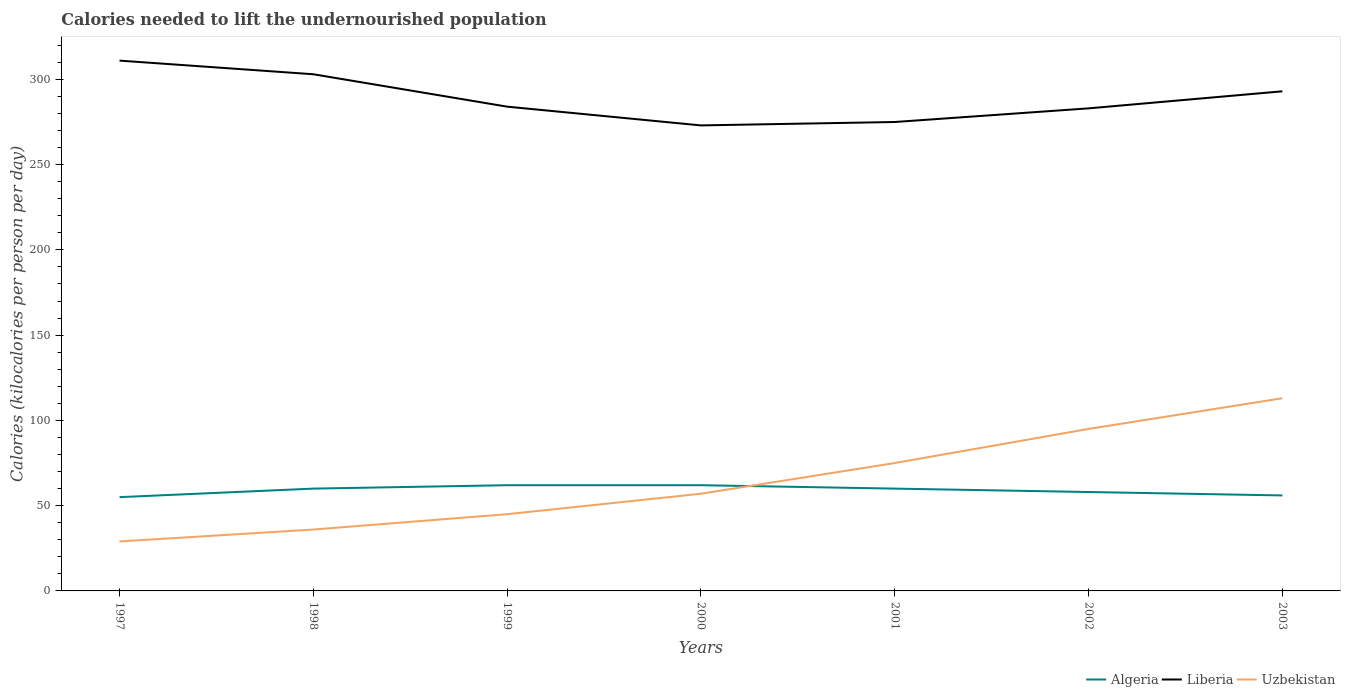Does the line corresponding to Algeria intersect with the line corresponding to Uzbekistan?
Offer a terse response. Yes. Is the number of lines equal to the number of legend labels?
Give a very brief answer. Yes. Across all years, what is the maximum total calories needed to lift the undernourished population in Liberia?
Give a very brief answer. 273. What is the total total calories needed to lift the undernourished population in Uzbekistan in the graph?
Make the answer very short. -28. What is the difference between the highest and the second highest total calories needed to lift the undernourished population in Uzbekistan?
Make the answer very short. 84. Does the graph contain grids?
Your answer should be compact. No. What is the title of the graph?
Ensure brevity in your answer.  Calories needed to lift the undernourished population. Does "Burundi" appear as one of the legend labels in the graph?
Offer a terse response. No. What is the label or title of the Y-axis?
Your answer should be very brief. Calories (kilocalories per person per day). What is the Calories (kilocalories per person per day) of Algeria in 1997?
Make the answer very short. 55. What is the Calories (kilocalories per person per day) in Liberia in 1997?
Provide a short and direct response. 311. What is the Calories (kilocalories per person per day) in Uzbekistan in 1997?
Your answer should be compact. 29. What is the Calories (kilocalories per person per day) in Algeria in 1998?
Ensure brevity in your answer.  60. What is the Calories (kilocalories per person per day) of Liberia in 1998?
Provide a short and direct response. 303. What is the Calories (kilocalories per person per day) of Liberia in 1999?
Your answer should be compact. 284. What is the Calories (kilocalories per person per day) of Liberia in 2000?
Keep it short and to the point. 273. What is the Calories (kilocalories per person per day) in Uzbekistan in 2000?
Your answer should be compact. 57. What is the Calories (kilocalories per person per day) in Liberia in 2001?
Provide a succinct answer. 275. What is the Calories (kilocalories per person per day) in Algeria in 2002?
Ensure brevity in your answer.  58. What is the Calories (kilocalories per person per day) of Liberia in 2002?
Provide a succinct answer. 283. What is the Calories (kilocalories per person per day) in Liberia in 2003?
Provide a short and direct response. 293. What is the Calories (kilocalories per person per day) in Uzbekistan in 2003?
Your answer should be compact. 113. Across all years, what is the maximum Calories (kilocalories per person per day) of Liberia?
Offer a terse response. 311. Across all years, what is the maximum Calories (kilocalories per person per day) of Uzbekistan?
Make the answer very short. 113. Across all years, what is the minimum Calories (kilocalories per person per day) in Liberia?
Your answer should be very brief. 273. Across all years, what is the minimum Calories (kilocalories per person per day) of Uzbekistan?
Provide a succinct answer. 29. What is the total Calories (kilocalories per person per day) of Algeria in the graph?
Your response must be concise. 413. What is the total Calories (kilocalories per person per day) in Liberia in the graph?
Your answer should be compact. 2022. What is the total Calories (kilocalories per person per day) of Uzbekistan in the graph?
Offer a very short reply. 450. What is the difference between the Calories (kilocalories per person per day) of Liberia in 1997 and that in 1998?
Make the answer very short. 8. What is the difference between the Calories (kilocalories per person per day) in Uzbekistan in 1997 and that in 1998?
Your response must be concise. -7. What is the difference between the Calories (kilocalories per person per day) in Algeria in 1997 and that in 1999?
Provide a succinct answer. -7. What is the difference between the Calories (kilocalories per person per day) in Uzbekistan in 1997 and that in 1999?
Offer a terse response. -16. What is the difference between the Calories (kilocalories per person per day) in Algeria in 1997 and that in 2000?
Ensure brevity in your answer.  -7. What is the difference between the Calories (kilocalories per person per day) in Liberia in 1997 and that in 2000?
Offer a terse response. 38. What is the difference between the Calories (kilocalories per person per day) in Uzbekistan in 1997 and that in 2000?
Ensure brevity in your answer.  -28. What is the difference between the Calories (kilocalories per person per day) of Uzbekistan in 1997 and that in 2001?
Keep it short and to the point. -46. What is the difference between the Calories (kilocalories per person per day) of Algeria in 1997 and that in 2002?
Your answer should be very brief. -3. What is the difference between the Calories (kilocalories per person per day) in Liberia in 1997 and that in 2002?
Ensure brevity in your answer.  28. What is the difference between the Calories (kilocalories per person per day) of Uzbekistan in 1997 and that in 2002?
Your answer should be very brief. -66. What is the difference between the Calories (kilocalories per person per day) in Uzbekistan in 1997 and that in 2003?
Your answer should be very brief. -84. What is the difference between the Calories (kilocalories per person per day) in Algeria in 1998 and that in 1999?
Keep it short and to the point. -2. What is the difference between the Calories (kilocalories per person per day) of Liberia in 1998 and that in 1999?
Provide a succinct answer. 19. What is the difference between the Calories (kilocalories per person per day) in Uzbekistan in 1998 and that in 1999?
Your answer should be very brief. -9. What is the difference between the Calories (kilocalories per person per day) in Uzbekistan in 1998 and that in 2000?
Offer a terse response. -21. What is the difference between the Calories (kilocalories per person per day) of Algeria in 1998 and that in 2001?
Give a very brief answer. 0. What is the difference between the Calories (kilocalories per person per day) in Uzbekistan in 1998 and that in 2001?
Offer a terse response. -39. What is the difference between the Calories (kilocalories per person per day) of Uzbekistan in 1998 and that in 2002?
Provide a succinct answer. -59. What is the difference between the Calories (kilocalories per person per day) of Liberia in 1998 and that in 2003?
Your response must be concise. 10. What is the difference between the Calories (kilocalories per person per day) of Uzbekistan in 1998 and that in 2003?
Your response must be concise. -77. What is the difference between the Calories (kilocalories per person per day) in Algeria in 1999 and that in 2000?
Provide a succinct answer. 0. What is the difference between the Calories (kilocalories per person per day) in Liberia in 1999 and that in 2000?
Keep it short and to the point. 11. What is the difference between the Calories (kilocalories per person per day) of Algeria in 1999 and that in 2001?
Ensure brevity in your answer.  2. What is the difference between the Calories (kilocalories per person per day) of Liberia in 1999 and that in 2001?
Offer a very short reply. 9. What is the difference between the Calories (kilocalories per person per day) of Uzbekistan in 1999 and that in 2001?
Your answer should be very brief. -30. What is the difference between the Calories (kilocalories per person per day) of Liberia in 1999 and that in 2002?
Provide a short and direct response. 1. What is the difference between the Calories (kilocalories per person per day) of Algeria in 1999 and that in 2003?
Provide a succinct answer. 6. What is the difference between the Calories (kilocalories per person per day) of Uzbekistan in 1999 and that in 2003?
Give a very brief answer. -68. What is the difference between the Calories (kilocalories per person per day) in Algeria in 2000 and that in 2001?
Offer a terse response. 2. What is the difference between the Calories (kilocalories per person per day) in Liberia in 2000 and that in 2001?
Give a very brief answer. -2. What is the difference between the Calories (kilocalories per person per day) of Uzbekistan in 2000 and that in 2001?
Provide a short and direct response. -18. What is the difference between the Calories (kilocalories per person per day) of Liberia in 2000 and that in 2002?
Your answer should be very brief. -10. What is the difference between the Calories (kilocalories per person per day) of Uzbekistan in 2000 and that in 2002?
Provide a short and direct response. -38. What is the difference between the Calories (kilocalories per person per day) in Liberia in 2000 and that in 2003?
Give a very brief answer. -20. What is the difference between the Calories (kilocalories per person per day) in Uzbekistan in 2000 and that in 2003?
Offer a terse response. -56. What is the difference between the Calories (kilocalories per person per day) of Liberia in 2001 and that in 2002?
Provide a short and direct response. -8. What is the difference between the Calories (kilocalories per person per day) of Uzbekistan in 2001 and that in 2002?
Offer a terse response. -20. What is the difference between the Calories (kilocalories per person per day) in Liberia in 2001 and that in 2003?
Ensure brevity in your answer.  -18. What is the difference between the Calories (kilocalories per person per day) of Uzbekistan in 2001 and that in 2003?
Give a very brief answer. -38. What is the difference between the Calories (kilocalories per person per day) of Algeria in 2002 and that in 2003?
Make the answer very short. 2. What is the difference between the Calories (kilocalories per person per day) of Liberia in 2002 and that in 2003?
Provide a short and direct response. -10. What is the difference between the Calories (kilocalories per person per day) in Algeria in 1997 and the Calories (kilocalories per person per day) in Liberia in 1998?
Keep it short and to the point. -248. What is the difference between the Calories (kilocalories per person per day) of Algeria in 1997 and the Calories (kilocalories per person per day) of Uzbekistan in 1998?
Make the answer very short. 19. What is the difference between the Calories (kilocalories per person per day) in Liberia in 1997 and the Calories (kilocalories per person per day) in Uzbekistan in 1998?
Keep it short and to the point. 275. What is the difference between the Calories (kilocalories per person per day) in Algeria in 1997 and the Calories (kilocalories per person per day) in Liberia in 1999?
Offer a very short reply. -229. What is the difference between the Calories (kilocalories per person per day) in Algeria in 1997 and the Calories (kilocalories per person per day) in Uzbekistan in 1999?
Your answer should be very brief. 10. What is the difference between the Calories (kilocalories per person per day) of Liberia in 1997 and the Calories (kilocalories per person per day) of Uzbekistan in 1999?
Offer a terse response. 266. What is the difference between the Calories (kilocalories per person per day) in Algeria in 1997 and the Calories (kilocalories per person per day) in Liberia in 2000?
Keep it short and to the point. -218. What is the difference between the Calories (kilocalories per person per day) in Algeria in 1997 and the Calories (kilocalories per person per day) in Uzbekistan in 2000?
Your response must be concise. -2. What is the difference between the Calories (kilocalories per person per day) in Liberia in 1997 and the Calories (kilocalories per person per day) in Uzbekistan in 2000?
Your answer should be compact. 254. What is the difference between the Calories (kilocalories per person per day) of Algeria in 1997 and the Calories (kilocalories per person per day) of Liberia in 2001?
Provide a succinct answer. -220. What is the difference between the Calories (kilocalories per person per day) in Algeria in 1997 and the Calories (kilocalories per person per day) in Uzbekistan in 2001?
Give a very brief answer. -20. What is the difference between the Calories (kilocalories per person per day) of Liberia in 1997 and the Calories (kilocalories per person per day) of Uzbekistan in 2001?
Give a very brief answer. 236. What is the difference between the Calories (kilocalories per person per day) of Algeria in 1997 and the Calories (kilocalories per person per day) of Liberia in 2002?
Offer a terse response. -228. What is the difference between the Calories (kilocalories per person per day) of Liberia in 1997 and the Calories (kilocalories per person per day) of Uzbekistan in 2002?
Your response must be concise. 216. What is the difference between the Calories (kilocalories per person per day) of Algeria in 1997 and the Calories (kilocalories per person per day) of Liberia in 2003?
Keep it short and to the point. -238. What is the difference between the Calories (kilocalories per person per day) in Algeria in 1997 and the Calories (kilocalories per person per day) in Uzbekistan in 2003?
Provide a short and direct response. -58. What is the difference between the Calories (kilocalories per person per day) of Liberia in 1997 and the Calories (kilocalories per person per day) of Uzbekistan in 2003?
Your answer should be very brief. 198. What is the difference between the Calories (kilocalories per person per day) in Algeria in 1998 and the Calories (kilocalories per person per day) in Liberia in 1999?
Keep it short and to the point. -224. What is the difference between the Calories (kilocalories per person per day) in Liberia in 1998 and the Calories (kilocalories per person per day) in Uzbekistan in 1999?
Keep it short and to the point. 258. What is the difference between the Calories (kilocalories per person per day) in Algeria in 1998 and the Calories (kilocalories per person per day) in Liberia in 2000?
Offer a terse response. -213. What is the difference between the Calories (kilocalories per person per day) of Liberia in 1998 and the Calories (kilocalories per person per day) of Uzbekistan in 2000?
Provide a short and direct response. 246. What is the difference between the Calories (kilocalories per person per day) of Algeria in 1998 and the Calories (kilocalories per person per day) of Liberia in 2001?
Give a very brief answer. -215. What is the difference between the Calories (kilocalories per person per day) of Algeria in 1998 and the Calories (kilocalories per person per day) of Uzbekistan in 2001?
Provide a succinct answer. -15. What is the difference between the Calories (kilocalories per person per day) in Liberia in 1998 and the Calories (kilocalories per person per day) in Uzbekistan in 2001?
Give a very brief answer. 228. What is the difference between the Calories (kilocalories per person per day) in Algeria in 1998 and the Calories (kilocalories per person per day) in Liberia in 2002?
Ensure brevity in your answer.  -223. What is the difference between the Calories (kilocalories per person per day) in Algeria in 1998 and the Calories (kilocalories per person per day) in Uzbekistan in 2002?
Offer a terse response. -35. What is the difference between the Calories (kilocalories per person per day) in Liberia in 1998 and the Calories (kilocalories per person per day) in Uzbekistan in 2002?
Offer a very short reply. 208. What is the difference between the Calories (kilocalories per person per day) in Algeria in 1998 and the Calories (kilocalories per person per day) in Liberia in 2003?
Give a very brief answer. -233. What is the difference between the Calories (kilocalories per person per day) of Algeria in 1998 and the Calories (kilocalories per person per day) of Uzbekistan in 2003?
Provide a succinct answer. -53. What is the difference between the Calories (kilocalories per person per day) in Liberia in 1998 and the Calories (kilocalories per person per day) in Uzbekistan in 2003?
Provide a short and direct response. 190. What is the difference between the Calories (kilocalories per person per day) in Algeria in 1999 and the Calories (kilocalories per person per day) in Liberia in 2000?
Your answer should be very brief. -211. What is the difference between the Calories (kilocalories per person per day) of Algeria in 1999 and the Calories (kilocalories per person per day) of Uzbekistan in 2000?
Make the answer very short. 5. What is the difference between the Calories (kilocalories per person per day) of Liberia in 1999 and the Calories (kilocalories per person per day) of Uzbekistan in 2000?
Offer a terse response. 227. What is the difference between the Calories (kilocalories per person per day) of Algeria in 1999 and the Calories (kilocalories per person per day) of Liberia in 2001?
Your response must be concise. -213. What is the difference between the Calories (kilocalories per person per day) of Algeria in 1999 and the Calories (kilocalories per person per day) of Uzbekistan in 2001?
Your answer should be compact. -13. What is the difference between the Calories (kilocalories per person per day) of Liberia in 1999 and the Calories (kilocalories per person per day) of Uzbekistan in 2001?
Your answer should be compact. 209. What is the difference between the Calories (kilocalories per person per day) in Algeria in 1999 and the Calories (kilocalories per person per day) in Liberia in 2002?
Offer a very short reply. -221. What is the difference between the Calories (kilocalories per person per day) of Algeria in 1999 and the Calories (kilocalories per person per day) of Uzbekistan in 2002?
Keep it short and to the point. -33. What is the difference between the Calories (kilocalories per person per day) of Liberia in 1999 and the Calories (kilocalories per person per day) of Uzbekistan in 2002?
Offer a very short reply. 189. What is the difference between the Calories (kilocalories per person per day) in Algeria in 1999 and the Calories (kilocalories per person per day) in Liberia in 2003?
Give a very brief answer. -231. What is the difference between the Calories (kilocalories per person per day) of Algeria in 1999 and the Calories (kilocalories per person per day) of Uzbekistan in 2003?
Your answer should be compact. -51. What is the difference between the Calories (kilocalories per person per day) in Liberia in 1999 and the Calories (kilocalories per person per day) in Uzbekistan in 2003?
Your answer should be very brief. 171. What is the difference between the Calories (kilocalories per person per day) of Algeria in 2000 and the Calories (kilocalories per person per day) of Liberia in 2001?
Ensure brevity in your answer.  -213. What is the difference between the Calories (kilocalories per person per day) of Algeria in 2000 and the Calories (kilocalories per person per day) of Uzbekistan in 2001?
Provide a short and direct response. -13. What is the difference between the Calories (kilocalories per person per day) in Liberia in 2000 and the Calories (kilocalories per person per day) in Uzbekistan in 2001?
Make the answer very short. 198. What is the difference between the Calories (kilocalories per person per day) of Algeria in 2000 and the Calories (kilocalories per person per day) of Liberia in 2002?
Offer a terse response. -221. What is the difference between the Calories (kilocalories per person per day) of Algeria in 2000 and the Calories (kilocalories per person per day) of Uzbekistan in 2002?
Keep it short and to the point. -33. What is the difference between the Calories (kilocalories per person per day) in Liberia in 2000 and the Calories (kilocalories per person per day) in Uzbekistan in 2002?
Offer a terse response. 178. What is the difference between the Calories (kilocalories per person per day) in Algeria in 2000 and the Calories (kilocalories per person per day) in Liberia in 2003?
Keep it short and to the point. -231. What is the difference between the Calories (kilocalories per person per day) of Algeria in 2000 and the Calories (kilocalories per person per day) of Uzbekistan in 2003?
Your answer should be compact. -51. What is the difference between the Calories (kilocalories per person per day) of Liberia in 2000 and the Calories (kilocalories per person per day) of Uzbekistan in 2003?
Provide a short and direct response. 160. What is the difference between the Calories (kilocalories per person per day) of Algeria in 2001 and the Calories (kilocalories per person per day) of Liberia in 2002?
Give a very brief answer. -223. What is the difference between the Calories (kilocalories per person per day) in Algeria in 2001 and the Calories (kilocalories per person per day) in Uzbekistan in 2002?
Offer a terse response. -35. What is the difference between the Calories (kilocalories per person per day) in Liberia in 2001 and the Calories (kilocalories per person per day) in Uzbekistan in 2002?
Your answer should be compact. 180. What is the difference between the Calories (kilocalories per person per day) of Algeria in 2001 and the Calories (kilocalories per person per day) of Liberia in 2003?
Your answer should be very brief. -233. What is the difference between the Calories (kilocalories per person per day) of Algeria in 2001 and the Calories (kilocalories per person per day) of Uzbekistan in 2003?
Provide a short and direct response. -53. What is the difference between the Calories (kilocalories per person per day) of Liberia in 2001 and the Calories (kilocalories per person per day) of Uzbekistan in 2003?
Your answer should be very brief. 162. What is the difference between the Calories (kilocalories per person per day) in Algeria in 2002 and the Calories (kilocalories per person per day) in Liberia in 2003?
Make the answer very short. -235. What is the difference between the Calories (kilocalories per person per day) of Algeria in 2002 and the Calories (kilocalories per person per day) of Uzbekistan in 2003?
Offer a terse response. -55. What is the difference between the Calories (kilocalories per person per day) of Liberia in 2002 and the Calories (kilocalories per person per day) of Uzbekistan in 2003?
Make the answer very short. 170. What is the average Calories (kilocalories per person per day) in Algeria per year?
Give a very brief answer. 59. What is the average Calories (kilocalories per person per day) of Liberia per year?
Offer a terse response. 288.86. What is the average Calories (kilocalories per person per day) of Uzbekistan per year?
Your answer should be very brief. 64.29. In the year 1997, what is the difference between the Calories (kilocalories per person per day) in Algeria and Calories (kilocalories per person per day) in Liberia?
Offer a terse response. -256. In the year 1997, what is the difference between the Calories (kilocalories per person per day) in Liberia and Calories (kilocalories per person per day) in Uzbekistan?
Keep it short and to the point. 282. In the year 1998, what is the difference between the Calories (kilocalories per person per day) in Algeria and Calories (kilocalories per person per day) in Liberia?
Keep it short and to the point. -243. In the year 1998, what is the difference between the Calories (kilocalories per person per day) of Algeria and Calories (kilocalories per person per day) of Uzbekistan?
Offer a terse response. 24. In the year 1998, what is the difference between the Calories (kilocalories per person per day) of Liberia and Calories (kilocalories per person per day) of Uzbekistan?
Make the answer very short. 267. In the year 1999, what is the difference between the Calories (kilocalories per person per day) in Algeria and Calories (kilocalories per person per day) in Liberia?
Offer a terse response. -222. In the year 1999, what is the difference between the Calories (kilocalories per person per day) in Algeria and Calories (kilocalories per person per day) in Uzbekistan?
Provide a short and direct response. 17. In the year 1999, what is the difference between the Calories (kilocalories per person per day) in Liberia and Calories (kilocalories per person per day) in Uzbekistan?
Make the answer very short. 239. In the year 2000, what is the difference between the Calories (kilocalories per person per day) of Algeria and Calories (kilocalories per person per day) of Liberia?
Keep it short and to the point. -211. In the year 2000, what is the difference between the Calories (kilocalories per person per day) in Algeria and Calories (kilocalories per person per day) in Uzbekistan?
Keep it short and to the point. 5. In the year 2000, what is the difference between the Calories (kilocalories per person per day) of Liberia and Calories (kilocalories per person per day) of Uzbekistan?
Keep it short and to the point. 216. In the year 2001, what is the difference between the Calories (kilocalories per person per day) of Algeria and Calories (kilocalories per person per day) of Liberia?
Offer a very short reply. -215. In the year 2001, what is the difference between the Calories (kilocalories per person per day) in Algeria and Calories (kilocalories per person per day) in Uzbekistan?
Offer a terse response. -15. In the year 2001, what is the difference between the Calories (kilocalories per person per day) in Liberia and Calories (kilocalories per person per day) in Uzbekistan?
Offer a very short reply. 200. In the year 2002, what is the difference between the Calories (kilocalories per person per day) of Algeria and Calories (kilocalories per person per day) of Liberia?
Keep it short and to the point. -225. In the year 2002, what is the difference between the Calories (kilocalories per person per day) in Algeria and Calories (kilocalories per person per day) in Uzbekistan?
Ensure brevity in your answer.  -37. In the year 2002, what is the difference between the Calories (kilocalories per person per day) of Liberia and Calories (kilocalories per person per day) of Uzbekistan?
Your answer should be compact. 188. In the year 2003, what is the difference between the Calories (kilocalories per person per day) of Algeria and Calories (kilocalories per person per day) of Liberia?
Your response must be concise. -237. In the year 2003, what is the difference between the Calories (kilocalories per person per day) in Algeria and Calories (kilocalories per person per day) in Uzbekistan?
Offer a very short reply. -57. In the year 2003, what is the difference between the Calories (kilocalories per person per day) of Liberia and Calories (kilocalories per person per day) of Uzbekistan?
Offer a very short reply. 180. What is the ratio of the Calories (kilocalories per person per day) of Liberia in 1997 to that in 1998?
Your answer should be compact. 1.03. What is the ratio of the Calories (kilocalories per person per day) in Uzbekistan in 1997 to that in 1998?
Provide a succinct answer. 0.81. What is the ratio of the Calories (kilocalories per person per day) in Algeria in 1997 to that in 1999?
Offer a very short reply. 0.89. What is the ratio of the Calories (kilocalories per person per day) in Liberia in 1997 to that in 1999?
Provide a succinct answer. 1.1. What is the ratio of the Calories (kilocalories per person per day) in Uzbekistan in 1997 to that in 1999?
Provide a succinct answer. 0.64. What is the ratio of the Calories (kilocalories per person per day) in Algeria in 1997 to that in 2000?
Give a very brief answer. 0.89. What is the ratio of the Calories (kilocalories per person per day) in Liberia in 1997 to that in 2000?
Your answer should be very brief. 1.14. What is the ratio of the Calories (kilocalories per person per day) of Uzbekistan in 1997 to that in 2000?
Provide a short and direct response. 0.51. What is the ratio of the Calories (kilocalories per person per day) in Algeria in 1997 to that in 2001?
Provide a succinct answer. 0.92. What is the ratio of the Calories (kilocalories per person per day) in Liberia in 1997 to that in 2001?
Your response must be concise. 1.13. What is the ratio of the Calories (kilocalories per person per day) of Uzbekistan in 1997 to that in 2001?
Offer a terse response. 0.39. What is the ratio of the Calories (kilocalories per person per day) of Algeria in 1997 to that in 2002?
Your response must be concise. 0.95. What is the ratio of the Calories (kilocalories per person per day) in Liberia in 1997 to that in 2002?
Your response must be concise. 1.1. What is the ratio of the Calories (kilocalories per person per day) in Uzbekistan in 1997 to that in 2002?
Your answer should be compact. 0.31. What is the ratio of the Calories (kilocalories per person per day) in Algeria in 1997 to that in 2003?
Offer a very short reply. 0.98. What is the ratio of the Calories (kilocalories per person per day) of Liberia in 1997 to that in 2003?
Make the answer very short. 1.06. What is the ratio of the Calories (kilocalories per person per day) in Uzbekistan in 1997 to that in 2003?
Your answer should be compact. 0.26. What is the ratio of the Calories (kilocalories per person per day) of Algeria in 1998 to that in 1999?
Offer a very short reply. 0.97. What is the ratio of the Calories (kilocalories per person per day) of Liberia in 1998 to that in 1999?
Offer a terse response. 1.07. What is the ratio of the Calories (kilocalories per person per day) in Algeria in 1998 to that in 2000?
Your response must be concise. 0.97. What is the ratio of the Calories (kilocalories per person per day) of Liberia in 1998 to that in 2000?
Provide a short and direct response. 1.11. What is the ratio of the Calories (kilocalories per person per day) of Uzbekistan in 1998 to that in 2000?
Keep it short and to the point. 0.63. What is the ratio of the Calories (kilocalories per person per day) of Algeria in 1998 to that in 2001?
Your answer should be very brief. 1. What is the ratio of the Calories (kilocalories per person per day) in Liberia in 1998 to that in 2001?
Offer a terse response. 1.1. What is the ratio of the Calories (kilocalories per person per day) of Uzbekistan in 1998 to that in 2001?
Ensure brevity in your answer.  0.48. What is the ratio of the Calories (kilocalories per person per day) of Algeria in 1998 to that in 2002?
Your answer should be compact. 1.03. What is the ratio of the Calories (kilocalories per person per day) of Liberia in 1998 to that in 2002?
Your response must be concise. 1.07. What is the ratio of the Calories (kilocalories per person per day) of Uzbekistan in 1998 to that in 2002?
Offer a terse response. 0.38. What is the ratio of the Calories (kilocalories per person per day) of Algeria in 1998 to that in 2003?
Give a very brief answer. 1.07. What is the ratio of the Calories (kilocalories per person per day) in Liberia in 1998 to that in 2003?
Provide a short and direct response. 1.03. What is the ratio of the Calories (kilocalories per person per day) in Uzbekistan in 1998 to that in 2003?
Provide a succinct answer. 0.32. What is the ratio of the Calories (kilocalories per person per day) of Liberia in 1999 to that in 2000?
Give a very brief answer. 1.04. What is the ratio of the Calories (kilocalories per person per day) of Uzbekistan in 1999 to that in 2000?
Your answer should be very brief. 0.79. What is the ratio of the Calories (kilocalories per person per day) in Algeria in 1999 to that in 2001?
Your response must be concise. 1.03. What is the ratio of the Calories (kilocalories per person per day) in Liberia in 1999 to that in 2001?
Make the answer very short. 1.03. What is the ratio of the Calories (kilocalories per person per day) of Uzbekistan in 1999 to that in 2001?
Your response must be concise. 0.6. What is the ratio of the Calories (kilocalories per person per day) of Algeria in 1999 to that in 2002?
Give a very brief answer. 1.07. What is the ratio of the Calories (kilocalories per person per day) in Uzbekistan in 1999 to that in 2002?
Provide a succinct answer. 0.47. What is the ratio of the Calories (kilocalories per person per day) of Algeria in 1999 to that in 2003?
Your answer should be compact. 1.11. What is the ratio of the Calories (kilocalories per person per day) in Liberia in 1999 to that in 2003?
Offer a terse response. 0.97. What is the ratio of the Calories (kilocalories per person per day) of Uzbekistan in 1999 to that in 2003?
Offer a terse response. 0.4. What is the ratio of the Calories (kilocalories per person per day) of Liberia in 2000 to that in 2001?
Keep it short and to the point. 0.99. What is the ratio of the Calories (kilocalories per person per day) in Uzbekistan in 2000 to that in 2001?
Provide a short and direct response. 0.76. What is the ratio of the Calories (kilocalories per person per day) of Algeria in 2000 to that in 2002?
Offer a terse response. 1.07. What is the ratio of the Calories (kilocalories per person per day) in Liberia in 2000 to that in 2002?
Your response must be concise. 0.96. What is the ratio of the Calories (kilocalories per person per day) in Algeria in 2000 to that in 2003?
Your answer should be very brief. 1.11. What is the ratio of the Calories (kilocalories per person per day) in Liberia in 2000 to that in 2003?
Provide a succinct answer. 0.93. What is the ratio of the Calories (kilocalories per person per day) of Uzbekistan in 2000 to that in 2003?
Offer a terse response. 0.5. What is the ratio of the Calories (kilocalories per person per day) of Algeria in 2001 to that in 2002?
Offer a very short reply. 1.03. What is the ratio of the Calories (kilocalories per person per day) in Liberia in 2001 to that in 2002?
Your answer should be compact. 0.97. What is the ratio of the Calories (kilocalories per person per day) of Uzbekistan in 2001 to that in 2002?
Provide a succinct answer. 0.79. What is the ratio of the Calories (kilocalories per person per day) of Algeria in 2001 to that in 2003?
Offer a terse response. 1.07. What is the ratio of the Calories (kilocalories per person per day) of Liberia in 2001 to that in 2003?
Your answer should be compact. 0.94. What is the ratio of the Calories (kilocalories per person per day) in Uzbekistan in 2001 to that in 2003?
Keep it short and to the point. 0.66. What is the ratio of the Calories (kilocalories per person per day) of Algeria in 2002 to that in 2003?
Give a very brief answer. 1.04. What is the ratio of the Calories (kilocalories per person per day) in Liberia in 2002 to that in 2003?
Your response must be concise. 0.97. What is the ratio of the Calories (kilocalories per person per day) in Uzbekistan in 2002 to that in 2003?
Offer a terse response. 0.84. What is the difference between the highest and the second highest Calories (kilocalories per person per day) of Algeria?
Ensure brevity in your answer.  0. What is the difference between the highest and the second highest Calories (kilocalories per person per day) of Uzbekistan?
Provide a short and direct response. 18. What is the difference between the highest and the lowest Calories (kilocalories per person per day) of Algeria?
Your answer should be compact. 7. What is the difference between the highest and the lowest Calories (kilocalories per person per day) in Liberia?
Give a very brief answer. 38. 